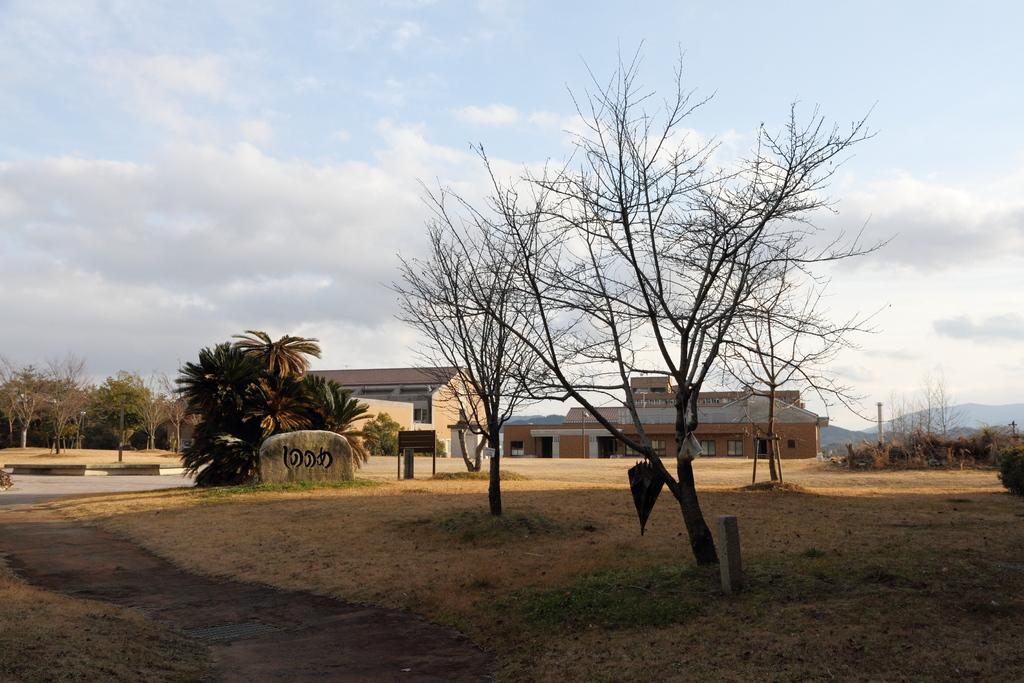What type of vegetation is at the bottom of the image? There is grass at the bottom of the image. What can be seen in the middle of the image? There are trees in the middle of the image. What type of structures are visible in the background of the image? There are buildings in the background of the image. What else can be seen in the background of the image? There are groups of trees in the background of the image. What is visible in the sky in the image? There are clouds in the sky. How many expansions are visible in the image? There is no mention of any expansions in the image; it features grass, trees, buildings, and clouds. Can you see a baseball game happening in the image? There is no indication of a baseball game or any sports activity in the image. 